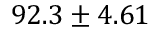Convert formula to latex. <formula><loc_0><loc_0><loc_500><loc_500>9 2 . 3 \pm 4 . 6 1</formula> 